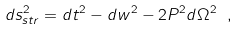<formula> <loc_0><loc_0><loc_500><loc_500>d s ^ { 2 } _ { s t r } = d t ^ { 2 } - d w ^ { 2 } - 2 P ^ { 2 } d \Omega ^ { 2 } \ ,</formula> 